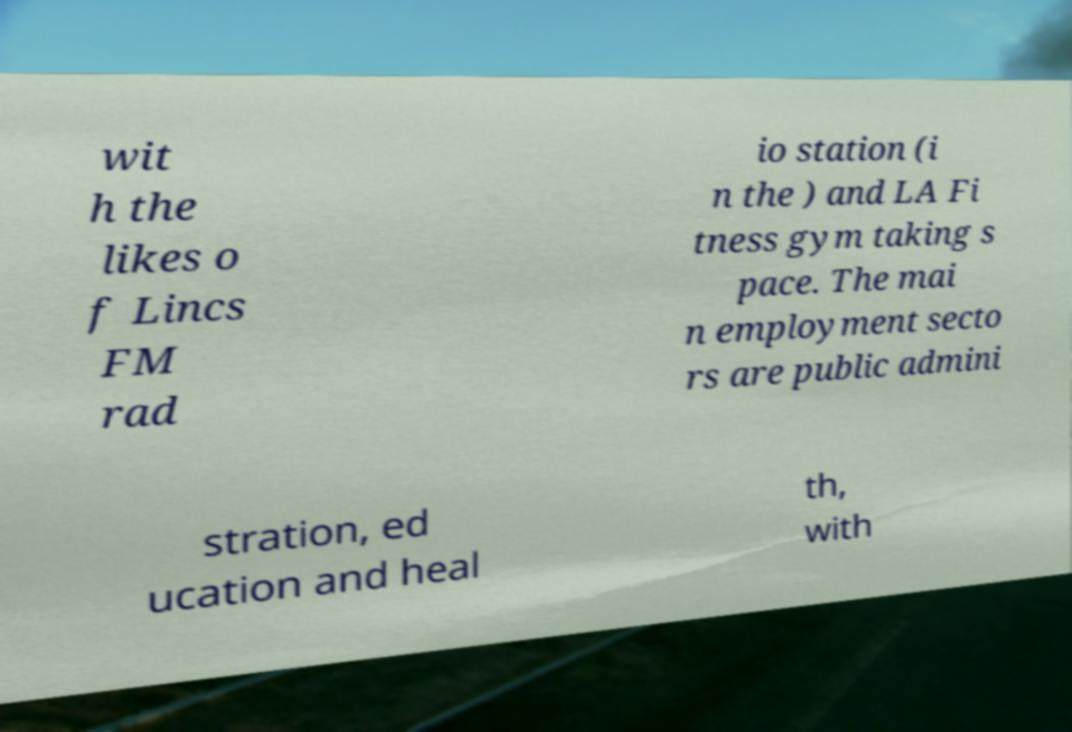I need the written content from this picture converted into text. Can you do that? wit h the likes o f Lincs FM rad io station (i n the ) and LA Fi tness gym taking s pace. The mai n employment secto rs are public admini stration, ed ucation and heal th, with 